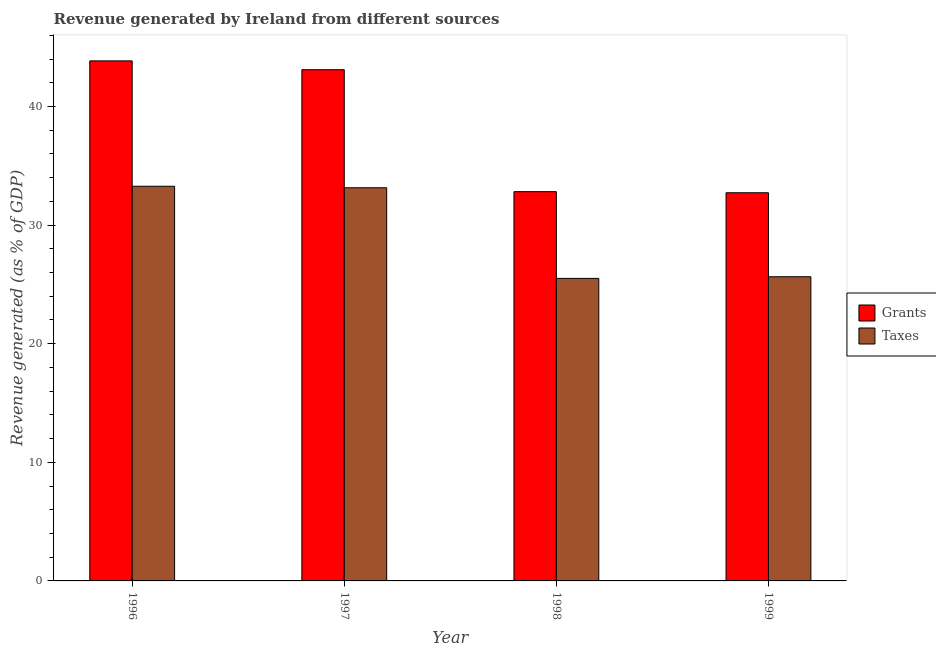Are the number of bars per tick equal to the number of legend labels?
Your answer should be very brief. Yes. How many bars are there on the 3rd tick from the left?
Provide a short and direct response. 2. How many bars are there on the 3rd tick from the right?
Make the answer very short. 2. What is the label of the 3rd group of bars from the left?
Make the answer very short. 1998. What is the revenue generated by taxes in 1998?
Provide a succinct answer. 25.51. Across all years, what is the maximum revenue generated by grants?
Offer a terse response. 43.85. Across all years, what is the minimum revenue generated by taxes?
Provide a succinct answer. 25.51. In which year was the revenue generated by grants maximum?
Offer a very short reply. 1996. In which year was the revenue generated by grants minimum?
Give a very brief answer. 1999. What is the total revenue generated by grants in the graph?
Your answer should be compact. 152.5. What is the difference between the revenue generated by grants in 1996 and that in 1999?
Give a very brief answer. 11.12. What is the difference between the revenue generated by taxes in 1996 and the revenue generated by grants in 1999?
Offer a very short reply. 7.63. What is the average revenue generated by taxes per year?
Provide a succinct answer. 29.4. What is the ratio of the revenue generated by grants in 1996 to that in 1999?
Your answer should be compact. 1.34. Is the difference between the revenue generated by taxes in 1998 and 1999 greater than the difference between the revenue generated by grants in 1998 and 1999?
Provide a succinct answer. No. What is the difference between the highest and the second highest revenue generated by taxes?
Your answer should be very brief. 0.13. What is the difference between the highest and the lowest revenue generated by grants?
Ensure brevity in your answer.  11.12. What does the 1st bar from the left in 1996 represents?
Provide a succinct answer. Grants. What does the 2nd bar from the right in 1997 represents?
Make the answer very short. Grants. How many bars are there?
Keep it short and to the point. 8. Are the values on the major ticks of Y-axis written in scientific E-notation?
Offer a terse response. No. Does the graph contain any zero values?
Give a very brief answer. No. Does the graph contain grids?
Give a very brief answer. No. Where does the legend appear in the graph?
Your answer should be very brief. Center right. How many legend labels are there?
Make the answer very short. 2. How are the legend labels stacked?
Provide a short and direct response. Vertical. What is the title of the graph?
Provide a short and direct response. Revenue generated by Ireland from different sources. What is the label or title of the X-axis?
Offer a very short reply. Year. What is the label or title of the Y-axis?
Your answer should be very brief. Revenue generated (as % of GDP). What is the Revenue generated (as % of GDP) of Grants in 1996?
Give a very brief answer. 43.85. What is the Revenue generated (as % of GDP) of Taxes in 1996?
Ensure brevity in your answer.  33.28. What is the Revenue generated (as % of GDP) in Grants in 1997?
Offer a terse response. 43.1. What is the Revenue generated (as % of GDP) in Taxes in 1997?
Give a very brief answer. 33.15. What is the Revenue generated (as % of GDP) of Grants in 1998?
Ensure brevity in your answer.  32.82. What is the Revenue generated (as % of GDP) of Taxes in 1998?
Provide a succinct answer. 25.51. What is the Revenue generated (as % of GDP) of Grants in 1999?
Your answer should be very brief. 32.73. What is the Revenue generated (as % of GDP) in Taxes in 1999?
Make the answer very short. 25.65. Across all years, what is the maximum Revenue generated (as % of GDP) in Grants?
Give a very brief answer. 43.85. Across all years, what is the maximum Revenue generated (as % of GDP) of Taxes?
Keep it short and to the point. 33.28. Across all years, what is the minimum Revenue generated (as % of GDP) in Grants?
Your answer should be compact. 32.73. Across all years, what is the minimum Revenue generated (as % of GDP) of Taxes?
Your answer should be compact. 25.51. What is the total Revenue generated (as % of GDP) in Grants in the graph?
Your response must be concise. 152.5. What is the total Revenue generated (as % of GDP) of Taxes in the graph?
Your answer should be compact. 117.58. What is the difference between the Revenue generated (as % of GDP) in Grants in 1996 and that in 1997?
Your answer should be very brief. 0.74. What is the difference between the Revenue generated (as % of GDP) in Taxes in 1996 and that in 1997?
Give a very brief answer. 0.13. What is the difference between the Revenue generated (as % of GDP) of Grants in 1996 and that in 1998?
Make the answer very short. 11.03. What is the difference between the Revenue generated (as % of GDP) of Taxes in 1996 and that in 1998?
Provide a short and direct response. 7.77. What is the difference between the Revenue generated (as % of GDP) in Grants in 1996 and that in 1999?
Your answer should be very brief. 11.12. What is the difference between the Revenue generated (as % of GDP) in Taxes in 1996 and that in 1999?
Provide a succinct answer. 7.63. What is the difference between the Revenue generated (as % of GDP) in Grants in 1997 and that in 1998?
Your answer should be compact. 10.28. What is the difference between the Revenue generated (as % of GDP) in Taxes in 1997 and that in 1998?
Provide a succinct answer. 7.64. What is the difference between the Revenue generated (as % of GDP) of Grants in 1997 and that in 1999?
Give a very brief answer. 10.38. What is the difference between the Revenue generated (as % of GDP) in Taxes in 1997 and that in 1999?
Keep it short and to the point. 7.5. What is the difference between the Revenue generated (as % of GDP) in Grants in 1998 and that in 1999?
Offer a terse response. 0.09. What is the difference between the Revenue generated (as % of GDP) of Taxes in 1998 and that in 1999?
Your answer should be compact. -0.14. What is the difference between the Revenue generated (as % of GDP) of Grants in 1996 and the Revenue generated (as % of GDP) of Taxes in 1997?
Your answer should be very brief. 10.7. What is the difference between the Revenue generated (as % of GDP) in Grants in 1996 and the Revenue generated (as % of GDP) in Taxes in 1998?
Make the answer very short. 18.34. What is the difference between the Revenue generated (as % of GDP) in Grants in 1996 and the Revenue generated (as % of GDP) in Taxes in 1999?
Make the answer very short. 18.2. What is the difference between the Revenue generated (as % of GDP) of Grants in 1997 and the Revenue generated (as % of GDP) of Taxes in 1998?
Ensure brevity in your answer.  17.59. What is the difference between the Revenue generated (as % of GDP) in Grants in 1997 and the Revenue generated (as % of GDP) in Taxes in 1999?
Give a very brief answer. 17.46. What is the difference between the Revenue generated (as % of GDP) of Grants in 1998 and the Revenue generated (as % of GDP) of Taxes in 1999?
Offer a terse response. 7.17. What is the average Revenue generated (as % of GDP) in Grants per year?
Your answer should be compact. 38.12. What is the average Revenue generated (as % of GDP) of Taxes per year?
Provide a succinct answer. 29.39. In the year 1996, what is the difference between the Revenue generated (as % of GDP) of Grants and Revenue generated (as % of GDP) of Taxes?
Offer a terse response. 10.57. In the year 1997, what is the difference between the Revenue generated (as % of GDP) of Grants and Revenue generated (as % of GDP) of Taxes?
Give a very brief answer. 9.95. In the year 1998, what is the difference between the Revenue generated (as % of GDP) of Grants and Revenue generated (as % of GDP) of Taxes?
Give a very brief answer. 7.31. In the year 1999, what is the difference between the Revenue generated (as % of GDP) in Grants and Revenue generated (as % of GDP) in Taxes?
Give a very brief answer. 7.08. What is the ratio of the Revenue generated (as % of GDP) in Grants in 1996 to that in 1997?
Your answer should be very brief. 1.02. What is the ratio of the Revenue generated (as % of GDP) in Grants in 1996 to that in 1998?
Provide a succinct answer. 1.34. What is the ratio of the Revenue generated (as % of GDP) in Taxes in 1996 to that in 1998?
Give a very brief answer. 1.3. What is the ratio of the Revenue generated (as % of GDP) in Grants in 1996 to that in 1999?
Your answer should be very brief. 1.34. What is the ratio of the Revenue generated (as % of GDP) of Taxes in 1996 to that in 1999?
Ensure brevity in your answer.  1.3. What is the ratio of the Revenue generated (as % of GDP) in Grants in 1997 to that in 1998?
Your answer should be very brief. 1.31. What is the ratio of the Revenue generated (as % of GDP) in Taxes in 1997 to that in 1998?
Ensure brevity in your answer.  1.3. What is the ratio of the Revenue generated (as % of GDP) in Grants in 1997 to that in 1999?
Give a very brief answer. 1.32. What is the ratio of the Revenue generated (as % of GDP) of Taxes in 1997 to that in 1999?
Keep it short and to the point. 1.29. What is the ratio of the Revenue generated (as % of GDP) in Grants in 1998 to that in 1999?
Provide a succinct answer. 1. What is the ratio of the Revenue generated (as % of GDP) of Taxes in 1998 to that in 1999?
Give a very brief answer. 0.99. What is the difference between the highest and the second highest Revenue generated (as % of GDP) in Grants?
Your response must be concise. 0.74. What is the difference between the highest and the second highest Revenue generated (as % of GDP) of Taxes?
Keep it short and to the point. 0.13. What is the difference between the highest and the lowest Revenue generated (as % of GDP) of Grants?
Keep it short and to the point. 11.12. What is the difference between the highest and the lowest Revenue generated (as % of GDP) in Taxes?
Your answer should be very brief. 7.77. 